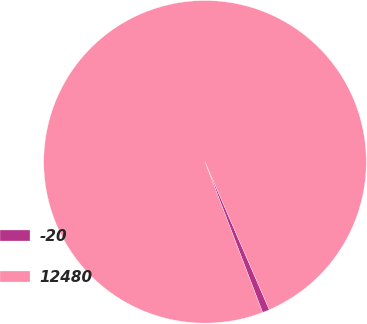<chart> <loc_0><loc_0><loc_500><loc_500><pie_chart><fcel>-20<fcel>12480<nl><fcel>0.71%<fcel>99.29%<nl></chart> 